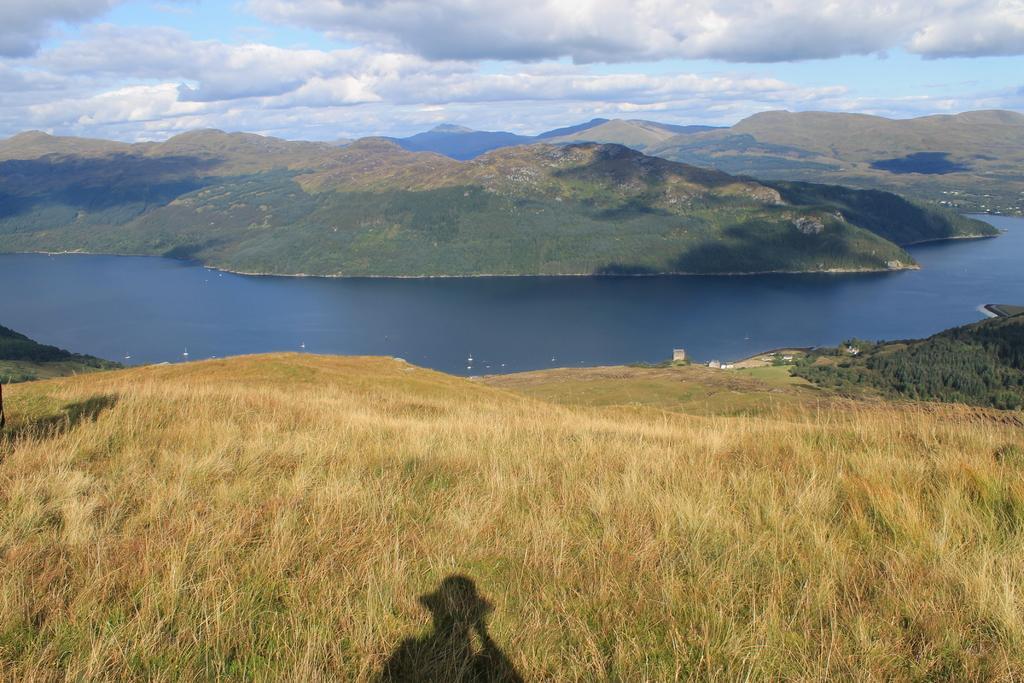How would you summarize this image in a sentence or two? There is a hill. On that there is grass and we can see a shadow of a person. In the back there is water, hills and sky with clouds. 